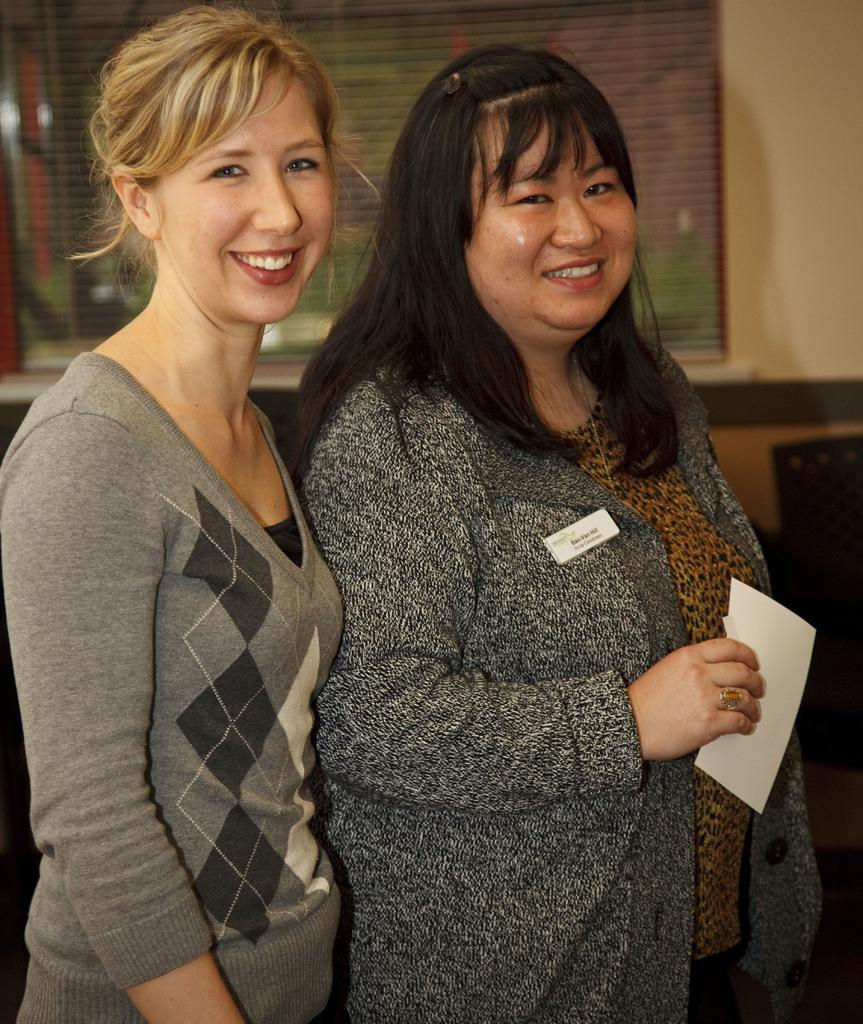How many people are in the image? There are two women in the image. What are the women doing in the image? The women are standing and smiling. What can be seen in the background of the image? There is a wall in the background of the image, and on that wall, there is a window. What type of sack can be seen hanging from the window in the image? There is no sack present in the image, and no sack is hanging from the window. 